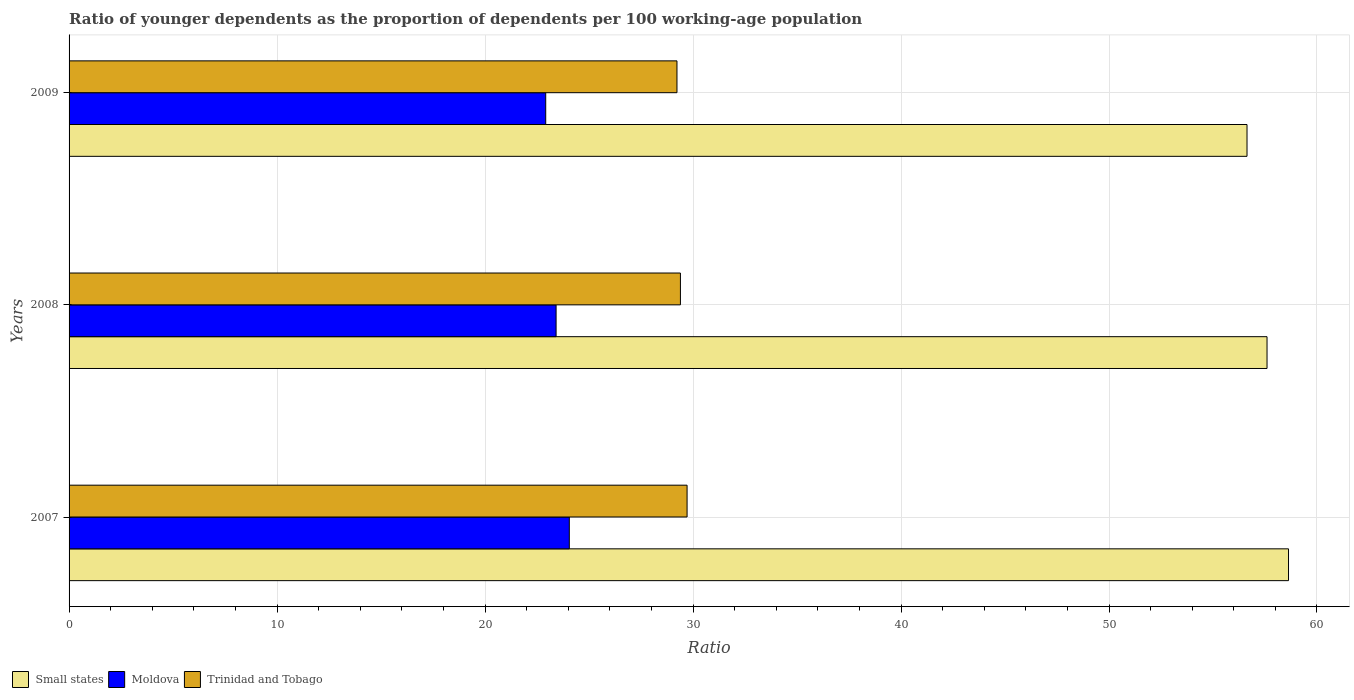Are the number of bars per tick equal to the number of legend labels?
Keep it short and to the point. Yes. How many bars are there on the 2nd tick from the bottom?
Ensure brevity in your answer.  3. What is the age dependency ratio(young) in Moldova in 2009?
Your response must be concise. 22.92. Across all years, what is the maximum age dependency ratio(young) in Trinidad and Tobago?
Your answer should be compact. 29.71. Across all years, what is the minimum age dependency ratio(young) in Small states?
Give a very brief answer. 56.64. In which year was the age dependency ratio(young) in Small states maximum?
Keep it short and to the point. 2007. In which year was the age dependency ratio(young) in Trinidad and Tobago minimum?
Offer a very short reply. 2009. What is the total age dependency ratio(young) in Moldova in the graph?
Your response must be concise. 70.39. What is the difference between the age dependency ratio(young) in Small states in 2008 and that in 2009?
Offer a very short reply. 0.96. What is the difference between the age dependency ratio(young) in Small states in 2009 and the age dependency ratio(young) in Moldova in 2008?
Your answer should be very brief. 33.22. What is the average age dependency ratio(young) in Trinidad and Tobago per year?
Make the answer very short. 29.45. In the year 2007, what is the difference between the age dependency ratio(young) in Trinidad and Tobago and age dependency ratio(young) in Small states?
Ensure brevity in your answer.  -28.92. In how many years, is the age dependency ratio(young) in Moldova greater than 56 ?
Your answer should be compact. 0. What is the ratio of the age dependency ratio(young) in Moldova in 2007 to that in 2009?
Keep it short and to the point. 1.05. Is the age dependency ratio(young) in Small states in 2007 less than that in 2008?
Make the answer very short. No. Is the difference between the age dependency ratio(young) in Trinidad and Tobago in 2008 and 2009 greater than the difference between the age dependency ratio(young) in Small states in 2008 and 2009?
Offer a very short reply. No. What is the difference between the highest and the second highest age dependency ratio(young) in Moldova?
Provide a succinct answer. 0.64. What is the difference between the highest and the lowest age dependency ratio(young) in Moldova?
Offer a terse response. 1.13. What does the 1st bar from the top in 2009 represents?
Offer a terse response. Trinidad and Tobago. What does the 3rd bar from the bottom in 2009 represents?
Ensure brevity in your answer.  Trinidad and Tobago. Are all the bars in the graph horizontal?
Provide a short and direct response. Yes. How many years are there in the graph?
Offer a very short reply. 3. What is the difference between two consecutive major ticks on the X-axis?
Give a very brief answer. 10. How many legend labels are there?
Your answer should be compact. 3. What is the title of the graph?
Provide a short and direct response. Ratio of younger dependents as the proportion of dependents per 100 working-age population. Does "New Zealand" appear as one of the legend labels in the graph?
Make the answer very short. No. What is the label or title of the X-axis?
Keep it short and to the point. Ratio. What is the Ratio in Small states in 2007?
Provide a short and direct response. 58.63. What is the Ratio in Moldova in 2007?
Your answer should be very brief. 24.05. What is the Ratio of Trinidad and Tobago in 2007?
Offer a terse response. 29.71. What is the Ratio in Small states in 2008?
Your answer should be compact. 57.6. What is the Ratio of Moldova in 2008?
Your answer should be very brief. 23.42. What is the Ratio of Trinidad and Tobago in 2008?
Your response must be concise. 29.39. What is the Ratio in Small states in 2009?
Make the answer very short. 56.64. What is the Ratio in Moldova in 2009?
Your answer should be compact. 22.92. What is the Ratio of Trinidad and Tobago in 2009?
Offer a very short reply. 29.23. Across all years, what is the maximum Ratio in Small states?
Offer a terse response. 58.63. Across all years, what is the maximum Ratio of Moldova?
Give a very brief answer. 24.05. Across all years, what is the maximum Ratio in Trinidad and Tobago?
Ensure brevity in your answer.  29.71. Across all years, what is the minimum Ratio of Small states?
Provide a short and direct response. 56.64. Across all years, what is the minimum Ratio of Moldova?
Provide a succinct answer. 22.92. Across all years, what is the minimum Ratio of Trinidad and Tobago?
Offer a very short reply. 29.23. What is the total Ratio of Small states in the graph?
Give a very brief answer. 172.87. What is the total Ratio in Moldova in the graph?
Offer a terse response. 70.39. What is the total Ratio of Trinidad and Tobago in the graph?
Your answer should be very brief. 88.34. What is the difference between the Ratio in Small states in 2007 and that in 2008?
Offer a very short reply. 1.03. What is the difference between the Ratio in Moldova in 2007 and that in 2008?
Give a very brief answer. 0.64. What is the difference between the Ratio in Trinidad and Tobago in 2007 and that in 2008?
Give a very brief answer. 0.32. What is the difference between the Ratio of Small states in 2007 and that in 2009?
Keep it short and to the point. 2. What is the difference between the Ratio of Moldova in 2007 and that in 2009?
Offer a terse response. 1.14. What is the difference between the Ratio of Trinidad and Tobago in 2007 and that in 2009?
Your response must be concise. 0.49. What is the difference between the Ratio of Small states in 2008 and that in 2009?
Your answer should be compact. 0.96. What is the difference between the Ratio of Moldova in 2008 and that in 2009?
Offer a terse response. 0.5. What is the difference between the Ratio of Trinidad and Tobago in 2008 and that in 2009?
Keep it short and to the point. 0.17. What is the difference between the Ratio in Small states in 2007 and the Ratio in Moldova in 2008?
Your answer should be very brief. 35.22. What is the difference between the Ratio of Small states in 2007 and the Ratio of Trinidad and Tobago in 2008?
Provide a short and direct response. 29.24. What is the difference between the Ratio of Moldova in 2007 and the Ratio of Trinidad and Tobago in 2008?
Provide a succinct answer. -5.34. What is the difference between the Ratio in Small states in 2007 and the Ratio in Moldova in 2009?
Offer a terse response. 35.71. What is the difference between the Ratio of Small states in 2007 and the Ratio of Trinidad and Tobago in 2009?
Ensure brevity in your answer.  29.4. What is the difference between the Ratio of Moldova in 2007 and the Ratio of Trinidad and Tobago in 2009?
Offer a terse response. -5.18. What is the difference between the Ratio in Small states in 2008 and the Ratio in Moldova in 2009?
Your response must be concise. 34.68. What is the difference between the Ratio in Small states in 2008 and the Ratio in Trinidad and Tobago in 2009?
Ensure brevity in your answer.  28.37. What is the difference between the Ratio in Moldova in 2008 and the Ratio in Trinidad and Tobago in 2009?
Ensure brevity in your answer.  -5.81. What is the average Ratio of Small states per year?
Keep it short and to the point. 57.62. What is the average Ratio in Moldova per year?
Make the answer very short. 23.46. What is the average Ratio of Trinidad and Tobago per year?
Offer a very short reply. 29.45. In the year 2007, what is the difference between the Ratio of Small states and Ratio of Moldova?
Your answer should be very brief. 34.58. In the year 2007, what is the difference between the Ratio in Small states and Ratio in Trinidad and Tobago?
Offer a terse response. 28.92. In the year 2007, what is the difference between the Ratio of Moldova and Ratio of Trinidad and Tobago?
Your response must be concise. -5.66. In the year 2008, what is the difference between the Ratio in Small states and Ratio in Moldova?
Make the answer very short. 34.18. In the year 2008, what is the difference between the Ratio of Small states and Ratio of Trinidad and Tobago?
Provide a succinct answer. 28.2. In the year 2008, what is the difference between the Ratio in Moldova and Ratio in Trinidad and Tobago?
Your answer should be very brief. -5.98. In the year 2009, what is the difference between the Ratio of Small states and Ratio of Moldova?
Offer a terse response. 33.72. In the year 2009, what is the difference between the Ratio in Small states and Ratio in Trinidad and Tobago?
Provide a short and direct response. 27.41. In the year 2009, what is the difference between the Ratio in Moldova and Ratio in Trinidad and Tobago?
Offer a very short reply. -6.31. What is the ratio of the Ratio in Small states in 2007 to that in 2008?
Your answer should be compact. 1.02. What is the ratio of the Ratio in Moldova in 2007 to that in 2008?
Your answer should be compact. 1.03. What is the ratio of the Ratio in Trinidad and Tobago in 2007 to that in 2008?
Make the answer very short. 1.01. What is the ratio of the Ratio of Small states in 2007 to that in 2009?
Offer a very short reply. 1.04. What is the ratio of the Ratio of Moldova in 2007 to that in 2009?
Your response must be concise. 1.05. What is the ratio of the Ratio in Trinidad and Tobago in 2007 to that in 2009?
Give a very brief answer. 1.02. What is the ratio of the Ratio of Moldova in 2008 to that in 2009?
Your response must be concise. 1.02. What is the difference between the highest and the second highest Ratio in Small states?
Give a very brief answer. 1.03. What is the difference between the highest and the second highest Ratio of Moldova?
Offer a terse response. 0.64. What is the difference between the highest and the second highest Ratio of Trinidad and Tobago?
Your response must be concise. 0.32. What is the difference between the highest and the lowest Ratio of Small states?
Make the answer very short. 2. What is the difference between the highest and the lowest Ratio of Moldova?
Offer a very short reply. 1.14. What is the difference between the highest and the lowest Ratio in Trinidad and Tobago?
Your answer should be compact. 0.49. 